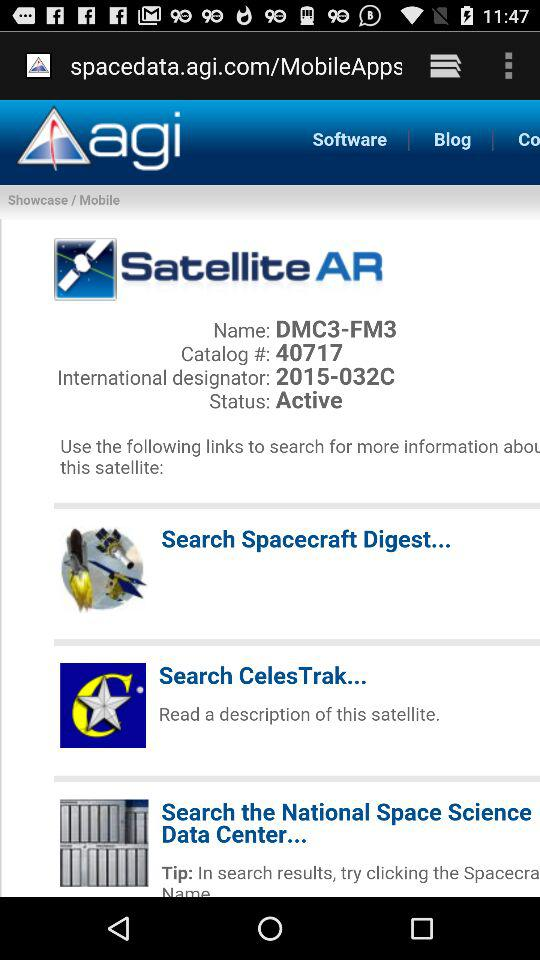What is the name of the satellite? The name of the satellite is DMC3-FM3. 